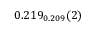Convert formula to latex. <formula><loc_0><loc_0><loc_500><loc_500>0 . 2 1 9 _ { 0 . 2 0 9 } ( 2 )</formula> 